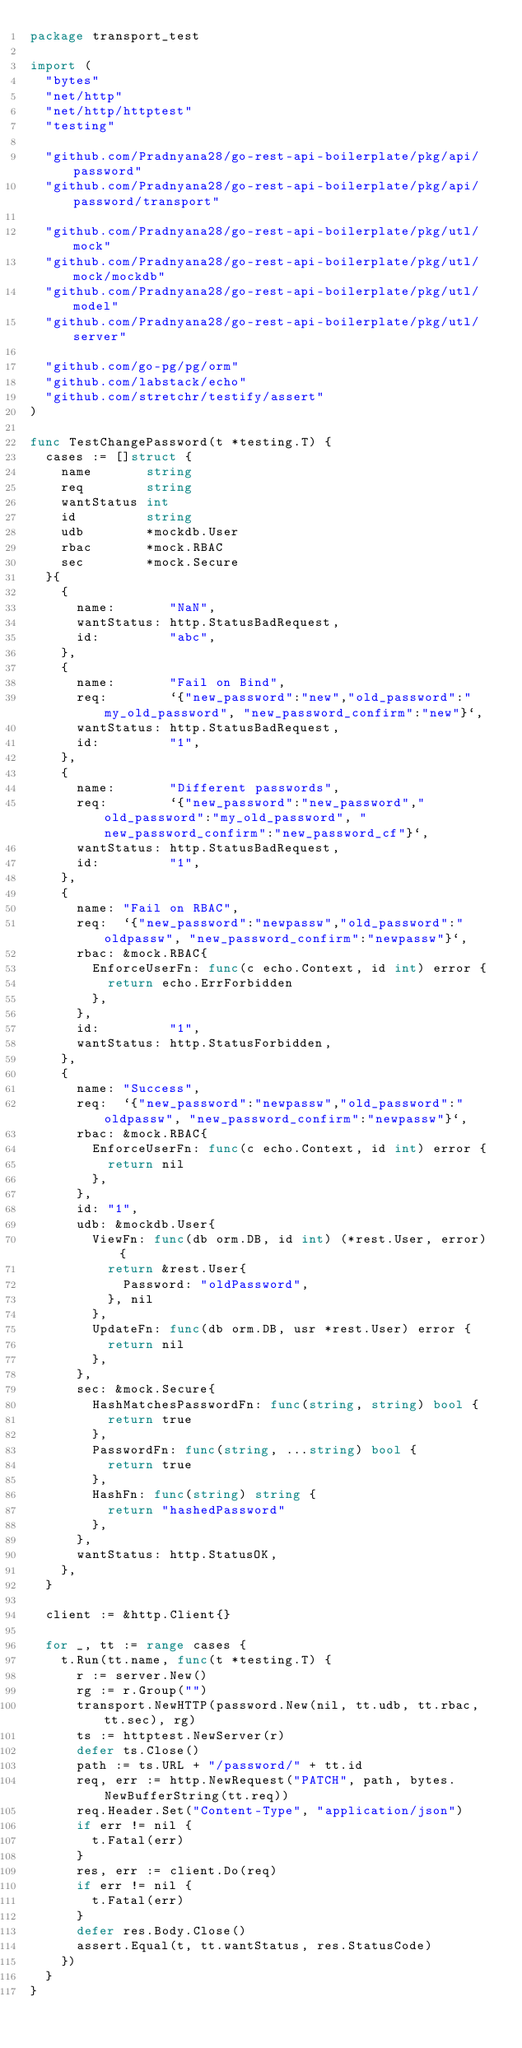Convert code to text. <code><loc_0><loc_0><loc_500><loc_500><_Go_>package transport_test

import (
	"bytes"
	"net/http"
	"net/http/httptest"
	"testing"

	"github.com/Pradnyana28/go-rest-api-boilerplate/pkg/api/password"
	"github.com/Pradnyana28/go-rest-api-boilerplate/pkg/api/password/transport"

	"github.com/Pradnyana28/go-rest-api-boilerplate/pkg/utl/mock"
	"github.com/Pradnyana28/go-rest-api-boilerplate/pkg/utl/mock/mockdb"
	"github.com/Pradnyana28/go-rest-api-boilerplate/pkg/utl/model"
	"github.com/Pradnyana28/go-rest-api-boilerplate/pkg/utl/server"

	"github.com/go-pg/pg/orm"
	"github.com/labstack/echo"
	"github.com/stretchr/testify/assert"
)

func TestChangePassword(t *testing.T) {
	cases := []struct {
		name       string
		req        string
		wantStatus int
		id         string
		udb        *mockdb.User
		rbac       *mock.RBAC
		sec        *mock.Secure
	}{
		{
			name:       "NaN",
			wantStatus: http.StatusBadRequest,
			id:         "abc",
		},
		{
			name:       "Fail on Bind",
			req:        `{"new_password":"new","old_password":"my_old_password", "new_password_confirm":"new"}`,
			wantStatus: http.StatusBadRequest,
			id:         "1",
		},
		{
			name:       "Different passwords",
			req:        `{"new_password":"new_password","old_password":"my_old_password", "new_password_confirm":"new_password_cf"}`,
			wantStatus: http.StatusBadRequest,
			id:         "1",
		},
		{
			name: "Fail on RBAC",
			req:  `{"new_password":"newpassw","old_password":"oldpassw", "new_password_confirm":"newpassw"}`,
			rbac: &mock.RBAC{
				EnforceUserFn: func(c echo.Context, id int) error {
					return echo.ErrForbidden
				},
			},
			id:         "1",
			wantStatus: http.StatusForbidden,
		},
		{
			name: "Success",
			req:  `{"new_password":"newpassw","old_password":"oldpassw", "new_password_confirm":"newpassw"}`,
			rbac: &mock.RBAC{
				EnforceUserFn: func(c echo.Context, id int) error {
					return nil
				},
			},
			id: "1",
			udb: &mockdb.User{
				ViewFn: func(db orm.DB, id int) (*rest.User, error) {
					return &rest.User{
						Password: "oldPassword",
					}, nil
				},
				UpdateFn: func(db orm.DB, usr *rest.User) error {
					return nil
				},
			},
			sec: &mock.Secure{
				HashMatchesPasswordFn: func(string, string) bool {
					return true
				},
				PasswordFn: func(string, ...string) bool {
					return true
				},
				HashFn: func(string) string {
					return "hashedPassword"
				},
			},
			wantStatus: http.StatusOK,
		},
	}

	client := &http.Client{}

	for _, tt := range cases {
		t.Run(tt.name, func(t *testing.T) {
			r := server.New()
			rg := r.Group("")
			transport.NewHTTP(password.New(nil, tt.udb, tt.rbac, tt.sec), rg)
			ts := httptest.NewServer(r)
			defer ts.Close()
			path := ts.URL + "/password/" + tt.id
			req, err := http.NewRequest("PATCH", path, bytes.NewBufferString(tt.req))
			req.Header.Set("Content-Type", "application/json")
			if err != nil {
				t.Fatal(err)
			}
			res, err := client.Do(req)
			if err != nil {
				t.Fatal(err)
			}
			defer res.Body.Close()
			assert.Equal(t, tt.wantStatus, res.StatusCode)
		})
	}
}
</code> 